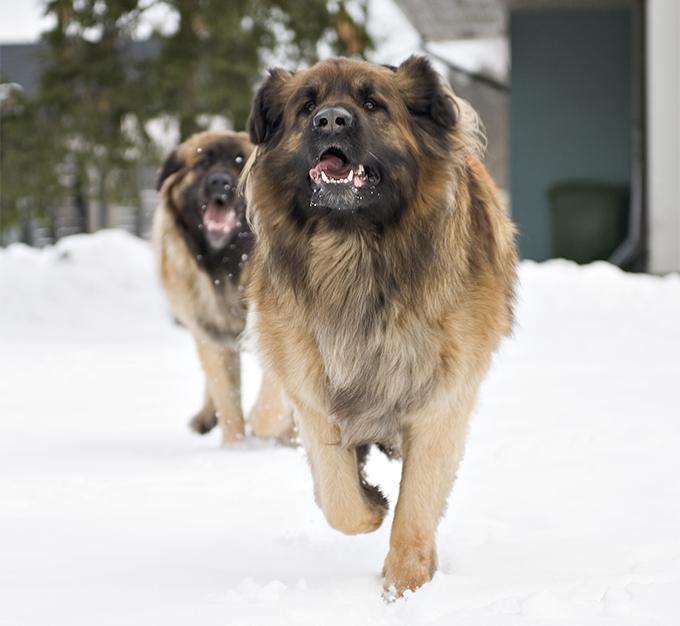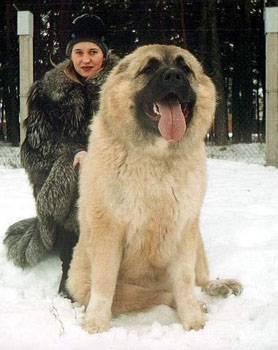The first image is the image on the left, the second image is the image on the right. For the images shown, is this caption "At least one dog is laying down." true? Answer yes or no. No. 